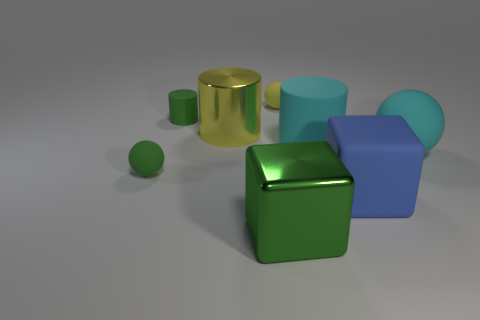How many blocks are cyan rubber things or large rubber things?
Give a very brief answer. 1. There is a sphere on the right side of the matte cylinder that is on the right side of the yellow object behind the big yellow metal thing; what size is it?
Keep it short and to the point. Large. The green matte thing that is the same size as the green matte ball is what shape?
Keep it short and to the point. Cylinder. What is the shape of the big yellow object?
Provide a short and direct response. Cylinder. Does the large cylinder that is left of the cyan matte cylinder have the same material as the tiny yellow object?
Your response must be concise. No. What is the size of the matte cylinder in front of the rubber cylinder that is left of the large yellow metallic cylinder?
Provide a succinct answer. Large. What color is the large rubber thing that is on the left side of the big cyan sphere and in front of the big matte cylinder?
Your answer should be very brief. Blue. What material is the yellow cylinder that is the same size as the rubber cube?
Your answer should be compact. Metal. How many other objects are there of the same material as the yellow cylinder?
Offer a very short reply. 1. Is the color of the tiny ball right of the green ball the same as the big block that is left of the large blue cube?
Provide a short and direct response. No. 